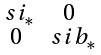Convert formula to latex. <formula><loc_0><loc_0><loc_500><loc_500>\begin{smallmatrix} \ s i _ { * } & 0 \\ 0 & \ s i b _ { * } \end{smallmatrix}</formula> 